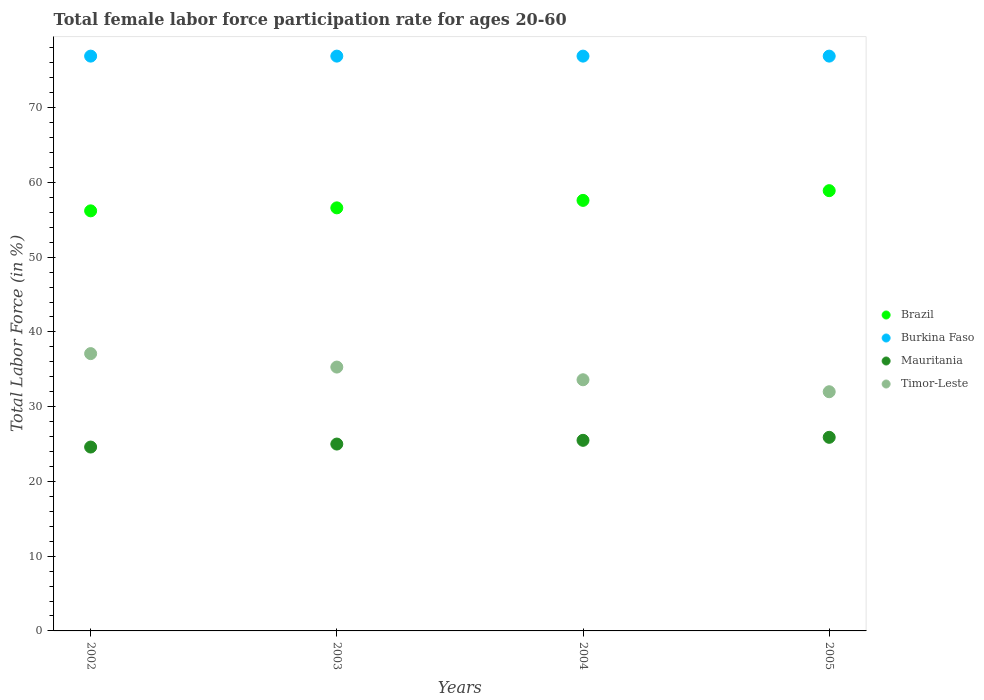How many different coloured dotlines are there?
Your answer should be compact. 4. What is the female labor force participation rate in Timor-Leste in 2004?
Your response must be concise. 33.6. Across all years, what is the maximum female labor force participation rate in Timor-Leste?
Ensure brevity in your answer.  37.1. Across all years, what is the minimum female labor force participation rate in Brazil?
Offer a terse response. 56.2. In which year was the female labor force participation rate in Brazil maximum?
Your answer should be very brief. 2005. In which year was the female labor force participation rate in Brazil minimum?
Ensure brevity in your answer.  2002. What is the total female labor force participation rate in Brazil in the graph?
Your answer should be compact. 229.3. What is the difference between the female labor force participation rate in Timor-Leste in 2003 and that in 2005?
Keep it short and to the point. 3.3. What is the difference between the female labor force participation rate in Timor-Leste in 2004 and the female labor force participation rate in Burkina Faso in 2005?
Keep it short and to the point. -43.3. What is the average female labor force participation rate in Timor-Leste per year?
Offer a terse response. 34.5. In the year 2003, what is the difference between the female labor force participation rate in Mauritania and female labor force participation rate in Brazil?
Offer a terse response. -31.6. In how many years, is the female labor force participation rate in Brazil greater than 40 %?
Provide a succinct answer. 4. What is the ratio of the female labor force participation rate in Burkina Faso in 2002 to that in 2004?
Your response must be concise. 1. Is the difference between the female labor force participation rate in Mauritania in 2002 and 2004 greater than the difference between the female labor force participation rate in Brazil in 2002 and 2004?
Your answer should be compact. Yes. What is the difference between the highest and the lowest female labor force participation rate in Timor-Leste?
Give a very brief answer. 5.1. Is it the case that in every year, the sum of the female labor force participation rate in Burkina Faso and female labor force participation rate in Brazil  is greater than the sum of female labor force participation rate in Mauritania and female labor force participation rate in Timor-Leste?
Your answer should be very brief. Yes. Is it the case that in every year, the sum of the female labor force participation rate in Timor-Leste and female labor force participation rate in Brazil  is greater than the female labor force participation rate in Mauritania?
Offer a terse response. Yes. Does the female labor force participation rate in Timor-Leste monotonically increase over the years?
Keep it short and to the point. No. Is the female labor force participation rate in Timor-Leste strictly greater than the female labor force participation rate in Burkina Faso over the years?
Offer a very short reply. No. Is the female labor force participation rate in Burkina Faso strictly less than the female labor force participation rate in Brazil over the years?
Provide a succinct answer. No. What is the difference between two consecutive major ticks on the Y-axis?
Provide a short and direct response. 10. Does the graph contain any zero values?
Offer a terse response. No. Where does the legend appear in the graph?
Provide a succinct answer. Center right. How many legend labels are there?
Offer a terse response. 4. How are the legend labels stacked?
Your answer should be very brief. Vertical. What is the title of the graph?
Offer a terse response. Total female labor force participation rate for ages 20-60. What is the label or title of the X-axis?
Give a very brief answer. Years. What is the label or title of the Y-axis?
Your answer should be compact. Total Labor Force (in %). What is the Total Labor Force (in %) of Brazil in 2002?
Offer a terse response. 56.2. What is the Total Labor Force (in %) in Burkina Faso in 2002?
Offer a very short reply. 76.9. What is the Total Labor Force (in %) in Mauritania in 2002?
Ensure brevity in your answer.  24.6. What is the Total Labor Force (in %) in Timor-Leste in 2002?
Provide a short and direct response. 37.1. What is the Total Labor Force (in %) of Brazil in 2003?
Provide a short and direct response. 56.6. What is the Total Labor Force (in %) of Burkina Faso in 2003?
Offer a very short reply. 76.9. What is the Total Labor Force (in %) in Timor-Leste in 2003?
Offer a terse response. 35.3. What is the Total Labor Force (in %) in Brazil in 2004?
Your response must be concise. 57.6. What is the Total Labor Force (in %) of Burkina Faso in 2004?
Give a very brief answer. 76.9. What is the Total Labor Force (in %) of Timor-Leste in 2004?
Your answer should be very brief. 33.6. What is the Total Labor Force (in %) of Brazil in 2005?
Offer a very short reply. 58.9. What is the Total Labor Force (in %) in Burkina Faso in 2005?
Provide a succinct answer. 76.9. What is the Total Labor Force (in %) of Mauritania in 2005?
Provide a succinct answer. 25.9. What is the Total Labor Force (in %) of Timor-Leste in 2005?
Make the answer very short. 32. Across all years, what is the maximum Total Labor Force (in %) of Brazil?
Your answer should be very brief. 58.9. Across all years, what is the maximum Total Labor Force (in %) in Burkina Faso?
Your answer should be compact. 76.9. Across all years, what is the maximum Total Labor Force (in %) in Mauritania?
Provide a short and direct response. 25.9. Across all years, what is the maximum Total Labor Force (in %) of Timor-Leste?
Give a very brief answer. 37.1. Across all years, what is the minimum Total Labor Force (in %) of Brazil?
Your answer should be very brief. 56.2. Across all years, what is the minimum Total Labor Force (in %) in Burkina Faso?
Give a very brief answer. 76.9. Across all years, what is the minimum Total Labor Force (in %) in Mauritania?
Your answer should be compact. 24.6. What is the total Total Labor Force (in %) in Brazil in the graph?
Offer a terse response. 229.3. What is the total Total Labor Force (in %) of Burkina Faso in the graph?
Keep it short and to the point. 307.6. What is the total Total Labor Force (in %) in Mauritania in the graph?
Ensure brevity in your answer.  101. What is the total Total Labor Force (in %) in Timor-Leste in the graph?
Your answer should be very brief. 138. What is the difference between the Total Labor Force (in %) in Brazil in 2002 and that in 2004?
Keep it short and to the point. -1.4. What is the difference between the Total Labor Force (in %) in Burkina Faso in 2002 and that in 2004?
Make the answer very short. 0. What is the difference between the Total Labor Force (in %) in Timor-Leste in 2002 and that in 2004?
Provide a succinct answer. 3.5. What is the difference between the Total Labor Force (in %) of Mauritania in 2002 and that in 2005?
Ensure brevity in your answer.  -1.3. What is the difference between the Total Labor Force (in %) of Timor-Leste in 2002 and that in 2005?
Make the answer very short. 5.1. What is the difference between the Total Labor Force (in %) of Brazil in 2003 and that in 2004?
Offer a terse response. -1. What is the difference between the Total Labor Force (in %) of Burkina Faso in 2003 and that in 2004?
Provide a succinct answer. 0. What is the difference between the Total Labor Force (in %) in Timor-Leste in 2003 and that in 2004?
Keep it short and to the point. 1.7. What is the difference between the Total Labor Force (in %) of Brazil in 2003 and that in 2005?
Keep it short and to the point. -2.3. What is the difference between the Total Labor Force (in %) in Burkina Faso in 2003 and that in 2005?
Give a very brief answer. 0. What is the difference between the Total Labor Force (in %) in Mauritania in 2003 and that in 2005?
Your answer should be compact. -0.9. What is the difference between the Total Labor Force (in %) in Timor-Leste in 2003 and that in 2005?
Provide a short and direct response. 3.3. What is the difference between the Total Labor Force (in %) in Burkina Faso in 2004 and that in 2005?
Make the answer very short. 0. What is the difference between the Total Labor Force (in %) in Timor-Leste in 2004 and that in 2005?
Ensure brevity in your answer.  1.6. What is the difference between the Total Labor Force (in %) of Brazil in 2002 and the Total Labor Force (in %) of Burkina Faso in 2003?
Give a very brief answer. -20.7. What is the difference between the Total Labor Force (in %) in Brazil in 2002 and the Total Labor Force (in %) in Mauritania in 2003?
Your answer should be compact. 31.2. What is the difference between the Total Labor Force (in %) of Brazil in 2002 and the Total Labor Force (in %) of Timor-Leste in 2003?
Your response must be concise. 20.9. What is the difference between the Total Labor Force (in %) in Burkina Faso in 2002 and the Total Labor Force (in %) in Mauritania in 2003?
Make the answer very short. 51.9. What is the difference between the Total Labor Force (in %) of Burkina Faso in 2002 and the Total Labor Force (in %) of Timor-Leste in 2003?
Your answer should be very brief. 41.6. What is the difference between the Total Labor Force (in %) in Mauritania in 2002 and the Total Labor Force (in %) in Timor-Leste in 2003?
Provide a succinct answer. -10.7. What is the difference between the Total Labor Force (in %) in Brazil in 2002 and the Total Labor Force (in %) in Burkina Faso in 2004?
Your answer should be very brief. -20.7. What is the difference between the Total Labor Force (in %) in Brazil in 2002 and the Total Labor Force (in %) in Mauritania in 2004?
Your answer should be very brief. 30.7. What is the difference between the Total Labor Force (in %) in Brazil in 2002 and the Total Labor Force (in %) in Timor-Leste in 2004?
Offer a very short reply. 22.6. What is the difference between the Total Labor Force (in %) in Burkina Faso in 2002 and the Total Labor Force (in %) in Mauritania in 2004?
Offer a terse response. 51.4. What is the difference between the Total Labor Force (in %) in Burkina Faso in 2002 and the Total Labor Force (in %) in Timor-Leste in 2004?
Give a very brief answer. 43.3. What is the difference between the Total Labor Force (in %) in Mauritania in 2002 and the Total Labor Force (in %) in Timor-Leste in 2004?
Offer a terse response. -9. What is the difference between the Total Labor Force (in %) in Brazil in 2002 and the Total Labor Force (in %) in Burkina Faso in 2005?
Offer a terse response. -20.7. What is the difference between the Total Labor Force (in %) in Brazil in 2002 and the Total Labor Force (in %) in Mauritania in 2005?
Give a very brief answer. 30.3. What is the difference between the Total Labor Force (in %) in Brazil in 2002 and the Total Labor Force (in %) in Timor-Leste in 2005?
Offer a terse response. 24.2. What is the difference between the Total Labor Force (in %) of Burkina Faso in 2002 and the Total Labor Force (in %) of Mauritania in 2005?
Keep it short and to the point. 51. What is the difference between the Total Labor Force (in %) of Burkina Faso in 2002 and the Total Labor Force (in %) of Timor-Leste in 2005?
Your answer should be compact. 44.9. What is the difference between the Total Labor Force (in %) in Mauritania in 2002 and the Total Labor Force (in %) in Timor-Leste in 2005?
Your answer should be compact. -7.4. What is the difference between the Total Labor Force (in %) of Brazil in 2003 and the Total Labor Force (in %) of Burkina Faso in 2004?
Give a very brief answer. -20.3. What is the difference between the Total Labor Force (in %) of Brazil in 2003 and the Total Labor Force (in %) of Mauritania in 2004?
Provide a short and direct response. 31.1. What is the difference between the Total Labor Force (in %) of Brazil in 2003 and the Total Labor Force (in %) of Timor-Leste in 2004?
Offer a very short reply. 23. What is the difference between the Total Labor Force (in %) of Burkina Faso in 2003 and the Total Labor Force (in %) of Mauritania in 2004?
Provide a succinct answer. 51.4. What is the difference between the Total Labor Force (in %) in Burkina Faso in 2003 and the Total Labor Force (in %) in Timor-Leste in 2004?
Your answer should be compact. 43.3. What is the difference between the Total Labor Force (in %) in Brazil in 2003 and the Total Labor Force (in %) in Burkina Faso in 2005?
Offer a very short reply. -20.3. What is the difference between the Total Labor Force (in %) in Brazil in 2003 and the Total Labor Force (in %) in Mauritania in 2005?
Provide a short and direct response. 30.7. What is the difference between the Total Labor Force (in %) of Brazil in 2003 and the Total Labor Force (in %) of Timor-Leste in 2005?
Provide a short and direct response. 24.6. What is the difference between the Total Labor Force (in %) in Burkina Faso in 2003 and the Total Labor Force (in %) in Timor-Leste in 2005?
Your answer should be very brief. 44.9. What is the difference between the Total Labor Force (in %) of Mauritania in 2003 and the Total Labor Force (in %) of Timor-Leste in 2005?
Provide a succinct answer. -7. What is the difference between the Total Labor Force (in %) in Brazil in 2004 and the Total Labor Force (in %) in Burkina Faso in 2005?
Ensure brevity in your answer.  -19.3. What is the difference between the Total Labor Force (in %) in Brazil in 2004 and the Total Labor Force (in %) in Mauritania in 2005?
Your answer should be compact. 31.7. What is the difference between the Total Labor Force (in %) of Brazil in 2004 and the Total Labor Force (in %) of Timor-Leste in 2005?
Make the answer very short. 25.6. What is the difference between the Total Labor Force (in %) of Burkina Faso in 2004 and the Total Labor Force (in %) of Timor-Leste in 2005?
Give a very brief answer. 44.9. What is the difference between the Total Labor Force (in %) of Mauritania in 2004 and the Total Labor Force (in %) of Timor-Leste in 2005?
Provide a short and direct response. -6.5. What is the average Total Labor Force (in %) in Brazil per year?
Give a very brief answer. 57.33. What is the average Total Labor Force (in %) in Burkina Faso per year?
Provide a short and direct response. 76.9. What is the average Total Labor Force (in %) in Mauritania per year?
Offer a terse response. 25.25. What is the average Total Labor Force (in %) of Timor-Leste per year?
Ensure brevity in your answer.  34.5. In the year 2002, what is the difference between the Total Labor Force (in %) of Brazil and Total Labor Force (in %) of Burkina Faso?
Provide a succinct answer. -20.7. In the year 2002, what is the difference between the Total Labor Force (in %) of Brazil and Total Labor Force (in %) of Mauritania?
Make the answer very short. 31.6. In the year 2002, what is the difference between the Total Labor Force (in %) of Burkina Faso and Total Labor Force (in %) of Mauritania?
Offer a terse response. 52.3. In the year 2002, what is the difference between the Total Labor Force (in %) of Burkina Faso and Total Labor Force (in %) of Timor-Leste?
Your answer should be very brief. 39.8. In the year 2003, what is the difference between the Total Labor Force (in %) of Brazil and Total Labor Force (in %) of Burkina Faso?
Offer a very short reply. -20.3. In the year 2003, what is the difference between the Total Labor Force (in %) in Brazil and Total Labor Force (in %) in Mauritania?
Give a very brief answer. 31.6. In the year 2003, what is the difference between the Total Labor Force (in %) of Brazil and Total Labor Force (in %) of Timor-Leste?
Your response must be concise. 21.3. In the year 2003, what is the difference between the Total Labor Force (in %) in Burkina Faso and Total Labor Force (in %) in Mauritania?
Give a very brief answer. 51.9. In the year 2003, what is the difference between the Total Labor Force (in %) in Burkina Faso and Total Labor Force (in %) in Timor-Leste?
Keep it short and to the point. 41.6. In the year 2004, what is the difference between the Total Labor Force (in %) of Brazil and Total Labor Force (in %) of Burkina Faso?
Your response must be concise. -19.3. In the year 2004, what is the difference between the Total Labor Force (in %) of Brazil and Total Labor Force (in %) of Mauritania?
Ensure brevity in your answer.  32.1. In the year 2004, what is the difference between the Total Labor Force (in %) of Brazil and Total Labor Force (in %) of Timor-Leste?
Give a very brief answer. 24. In the year 2004, what is the difference between the Total Labor Force (in %) in Burkina Faso and Total Labor Force (in %) in Mauritania?
Make the answer very short. 51.4. In the year 2004, what is the difference between the Total Labor Force (in %) of Burkina Faso and Total Labor Force (in %) of Timor-Leste?
Your answer should be compact. 43.3. In the year 2005, what is the difference between the Total Labor Force (in %) in Brazil and Total Labor Force (in %) in Burkina Faso?
Ensure brevity in your answer.  -18. In the year 2005, what is the difference between the Total Labor Force (in %) in Brazil and Total Labor Force (in %) in Mauritania?
Ensure brevity in your answer.  33. In the year 2005, what is the difference between the Total Labor Force (in %) of Brazil and Total Labor Force (in %) of Timor-Leste?
Your answer should be very brief. 26.9. In the year 2005, what is the difference between the Total Labor Force (in %) of Burkina Faso and Total Labor Force (in %) of Mauritania?
Keep it short and to the point. 51. In the year 2005, what is the difference between the Total Labor Force (in %) in Burkina Faso and Total Labor Force (in %) in Timor-Leste?
Provide a short and direct response. 44.9. What is the ratio of the Total Labor Force (in %) of Burkina Faso in 2002 to that in 2003?
Provide a succinct answer. 1. What is the ratio of the Total Labor Force (in %) in Timor-Leste in 2002 to that in 2003?
Provide a succinct answer. 1.05. What is the ratio of the Total Labor Force (in %) of Brazil in 2002 to that in 2004?
Your response must be concise. 0.98. What is the ratio of the Total Labor Force (in %) of Burkina Faso in 2002 to that in 2004?
Your answer should be very brief. 1. What is the ratio of the Total Labor Force (in %) of Mauritania in 2002 to that in 2004?
Ensure brevity in your answer.  0.96. What is the ratio of the Total Labor Force (in %) in Timor-Leste in 2002 to that in 2004?
Offer a very short reply. 1.1. What is the ratio of the Total Labor Force (in %) of Brazil in 2002 to that in 2005?
Your answer should be very brief. 0.95. What is the ratio of the Total Labor Force (in %) of Burkina Faso in 2002 to that in 2005?
Keep it short and to the point. 1. What is the ratio of the Total Labor Force (in %) in Mauritania in 2002 to that in 2005?
Offer a terse response. 0.95. What is the ratio of the Total Labor Force (in %) in Timor-Leste in 2002 to that in 2005?
Ensure brevity in your answer.  1.16. What is the ratio of the Total Labor Force (in %) of Brazil in 2003 to that in 2004?
Your answer should be compact. 0.98. What is the ratio of the Total Labor Force (in %) in Burkina Faso in 2003 to that in 2004?
Keep it short and to the point. 1. What is the ratio of the Total Labor Force (in %) of Mauritania in 2003 to that in 2004?
Provide a short and direct response. 0.98. What is the ratio of the Total Labor Force (in %) of Timor-Leste in 2003 to that in 2004?
Make the answer very short. 1.05. What is the ratio of the Total Labor Force (in %) of Mauritania in 2003 to that in 2005?
Your response must be concise. 0.97. What is the ratio of the Total Labor Force (in %) in Timor-Leste in 2003 to that in 2005?
Give a very brief answer. 1.1. What is the ratio of the Total Labor Force (in %) in Brazil in 2004 to that in 2005?
Give a very brief answer. 0.98. What is the ratio of the Total Labor Force (in %) in Mauritania in 2004 to that in 2005?
Your answer should be very brief. 0.98. What is the ratio of the Total Labor Force (in %) of Timor-Leste in 2004 to that in 2005?
Give a very brief answer. 1.05. What is the difference between the highest and the second highest Total Labor Force (in %) in Brazil?
Your response must be concise. 1.3. What is the difference between the highest and the second highest Total Labor Force (in %) of Burkina Faso?
Keep it short and to the point. 0. What is the difference between the highest and the lowest Total Labor Force (in %) in Brazil?
Your answer should be compact. 2.7. What is the difference between the highest and the lowest Total Labor Force (in %) in Burkina Faso?
Provide a succinct answer. 0. What is the difference between the highest and the lowest Total Labor Force (in %) of Mauritania?
Your answer should be compact. 1.3. 